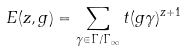<formula> <loc_0><loc_0><loc_500><loc_500>E ( z , g ) = \sum _ { \gamma \in \Gamma / \Gamma _ { \infty } } t ( g \gamma ) ^ { z + 1 }</formula> 